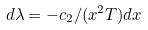Convert formula to latex. <formula><loc_0><loc_0><loc_500><loc_500>d \lambda = - c _ { 2 } / ( x ^ { 2 } T ) d x</formula> 